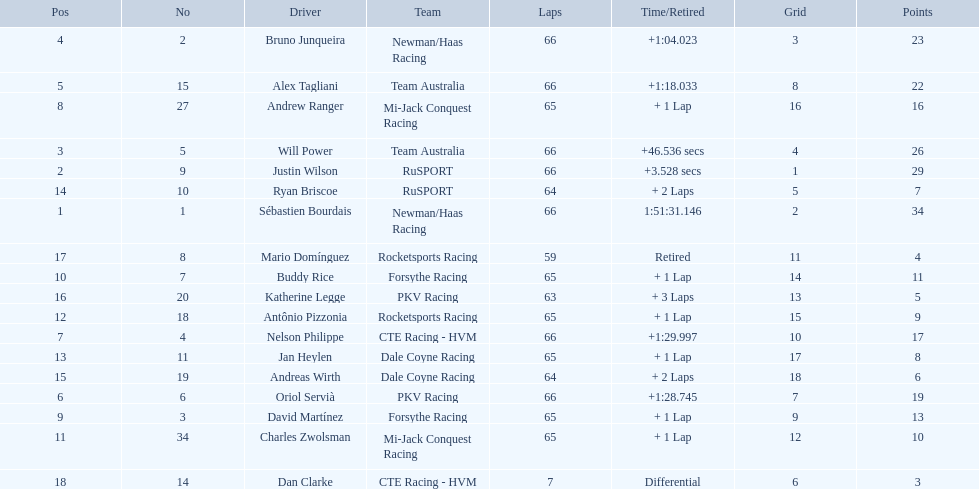At the 2006 gran premio telmex, who scored the highest number of points? Sébastien Bourdais. 